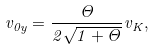Convert formula to latex. <formula><loc_0><loc_0><loc_500><loc_500>v _ { 0 y } = \frac { \Theta } { 2 \sqrt { 1 + \Theta } } v _ { K } ,</formula> 